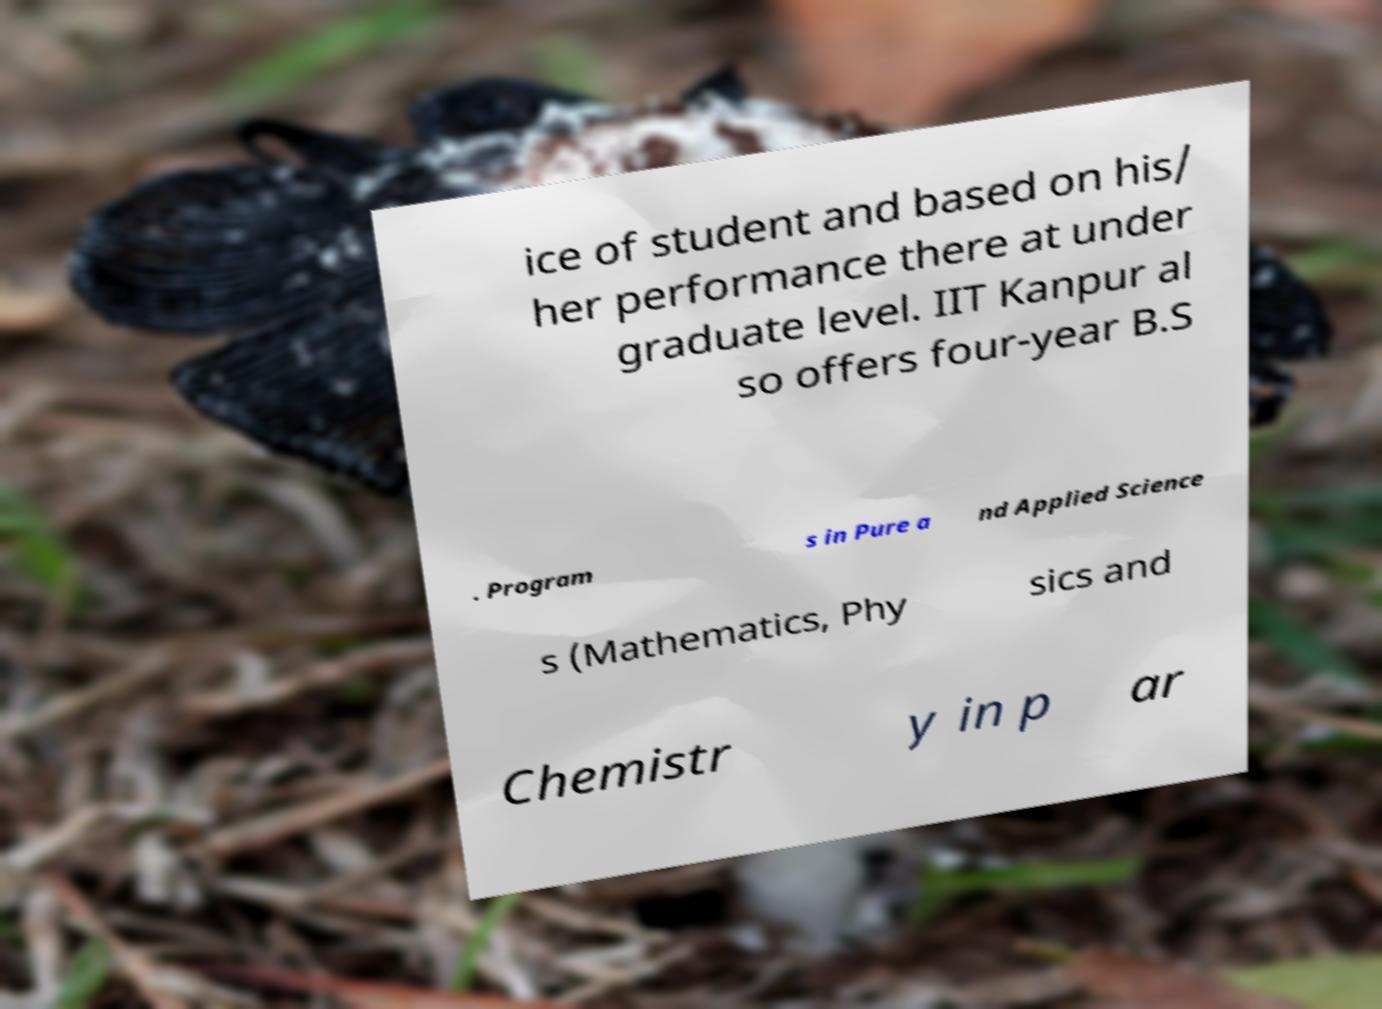Could you extract and type out the text from this image? ice of student and based on his/ her performance there at under graduate level. IIT Kanpur al so offers four-year B.S . Program s in Pure a nd Applied Science s (Mathematics, Phy sics and Chemistr y in p ar 